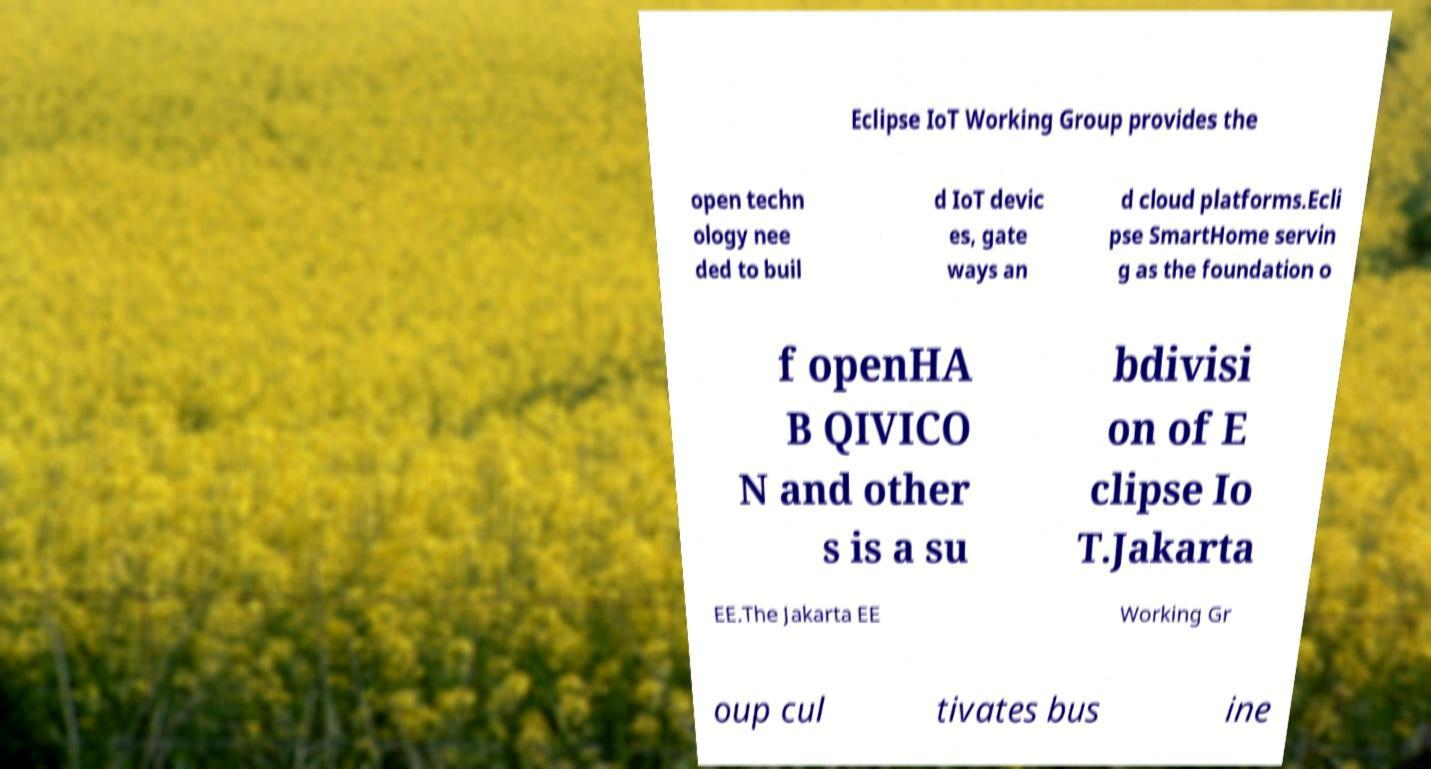Could you extract and type out the text from this image? Eclipse IoT Working Group provides the open techn ology nee ded to buil d IoT devic es, gate ways an d cloud platforms.Ecli pse SmartHome servin g as the foundation o f openHA B QIVICO N and other s is a su bdivisi on of E clipse Io T.Jakarta EE.The Jakarta EE Working Gr oup cul tivates bus ine 